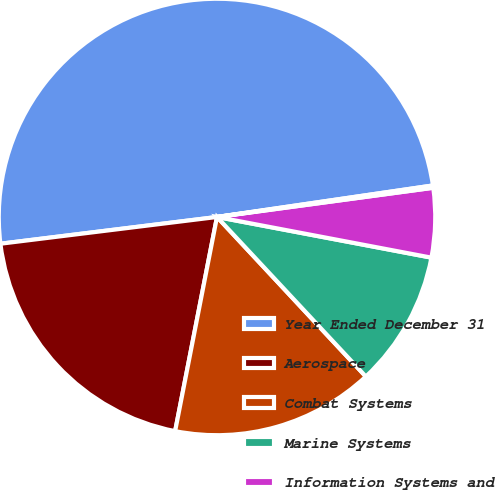Convert chart to OTSL. <chart><loc_0><loc_0><loc_500><loc_500><pie_chart><fcel>Year Ended December 31<fcel>Aerospace<fcel>Combat Systems<fcel>Marine Systems<fcel>Information Systems and<fcel>Corporate<nl><fcel>49.65%<fcel>19.97%<fcel>15.02%<fcel>10.07%<fcel>5.12%<fcel>0.17%<nl></chart> 